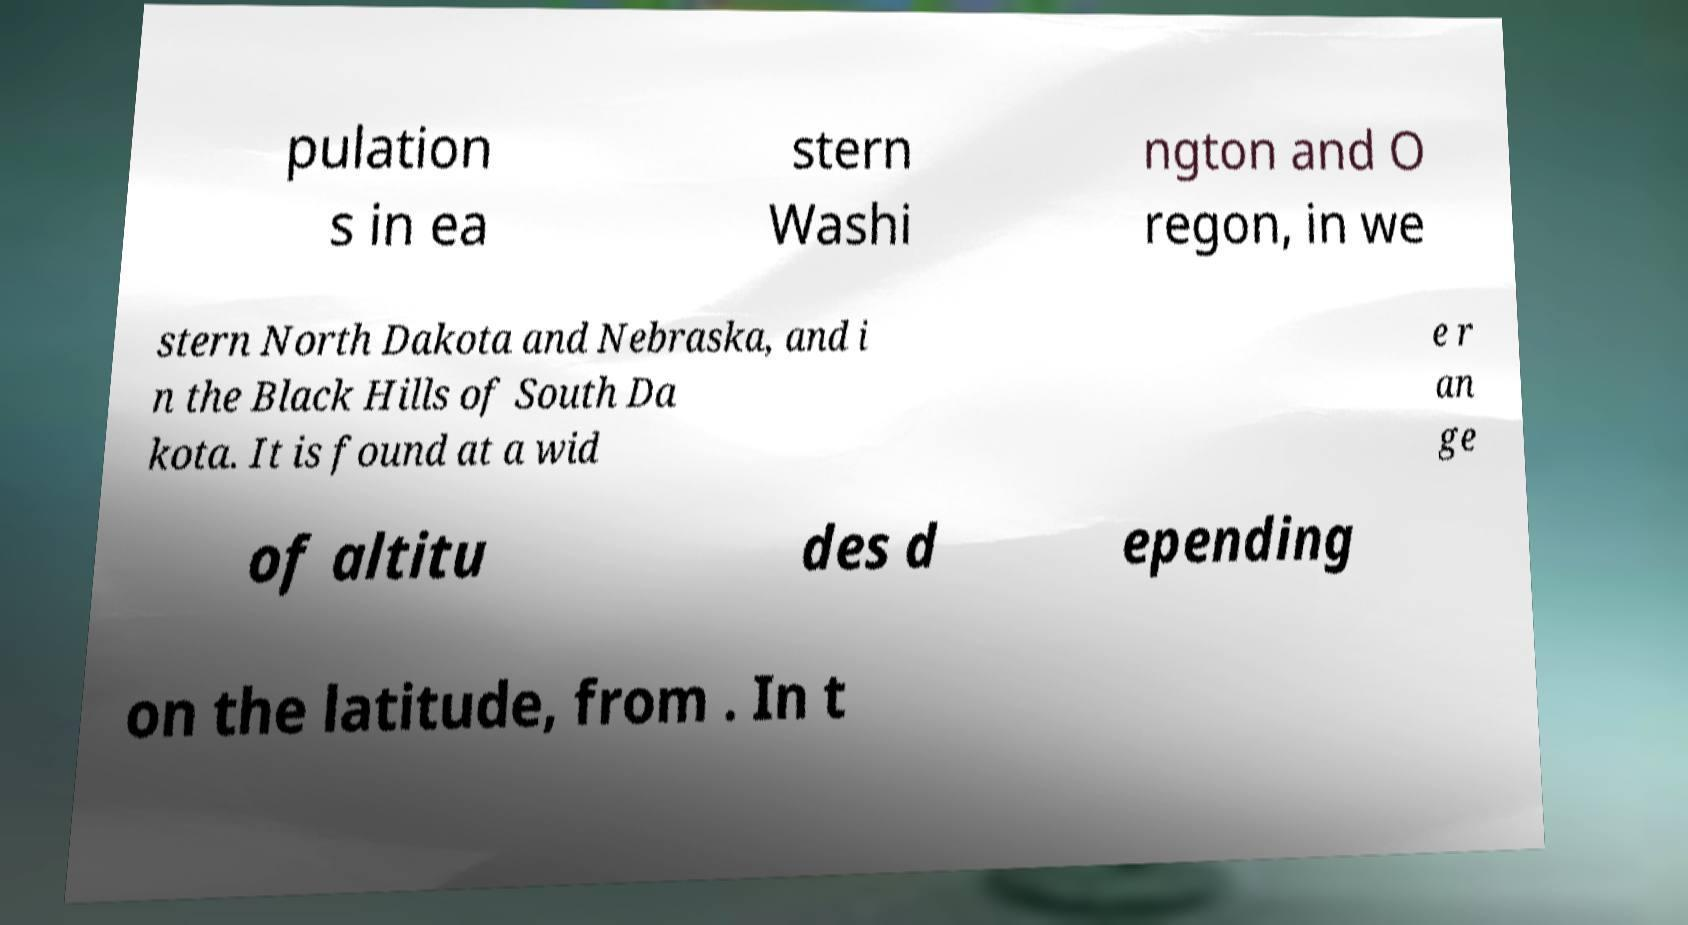Can you read and provide the text displayed in the image?This photo seems to have some interesting text. Can you extract and type it out for me? pulation s in ea stern Washi ngton and O regon, in we stern North Dakota and Nebraska, and i n the Black Hills of South Da kota. It is found at a wid e r an ge of altitu des d epending on the latitude, from . In t 